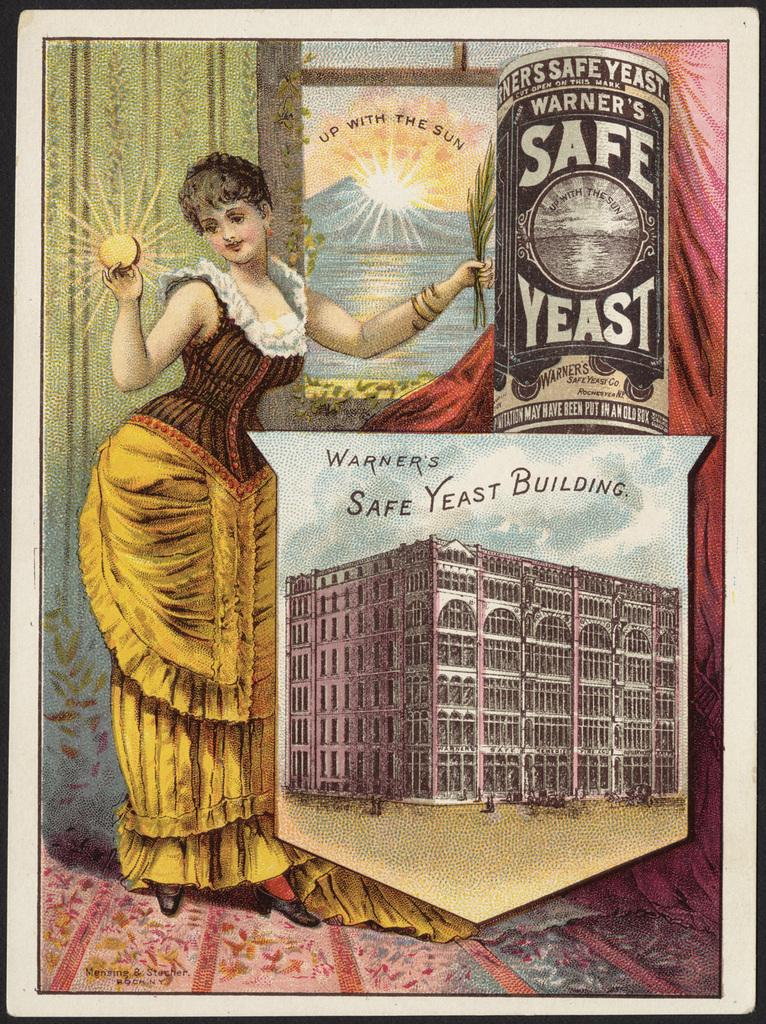<image>
Write a terse but informative summary of the picture. A very old advertisement for Warner's Safe Yeast 